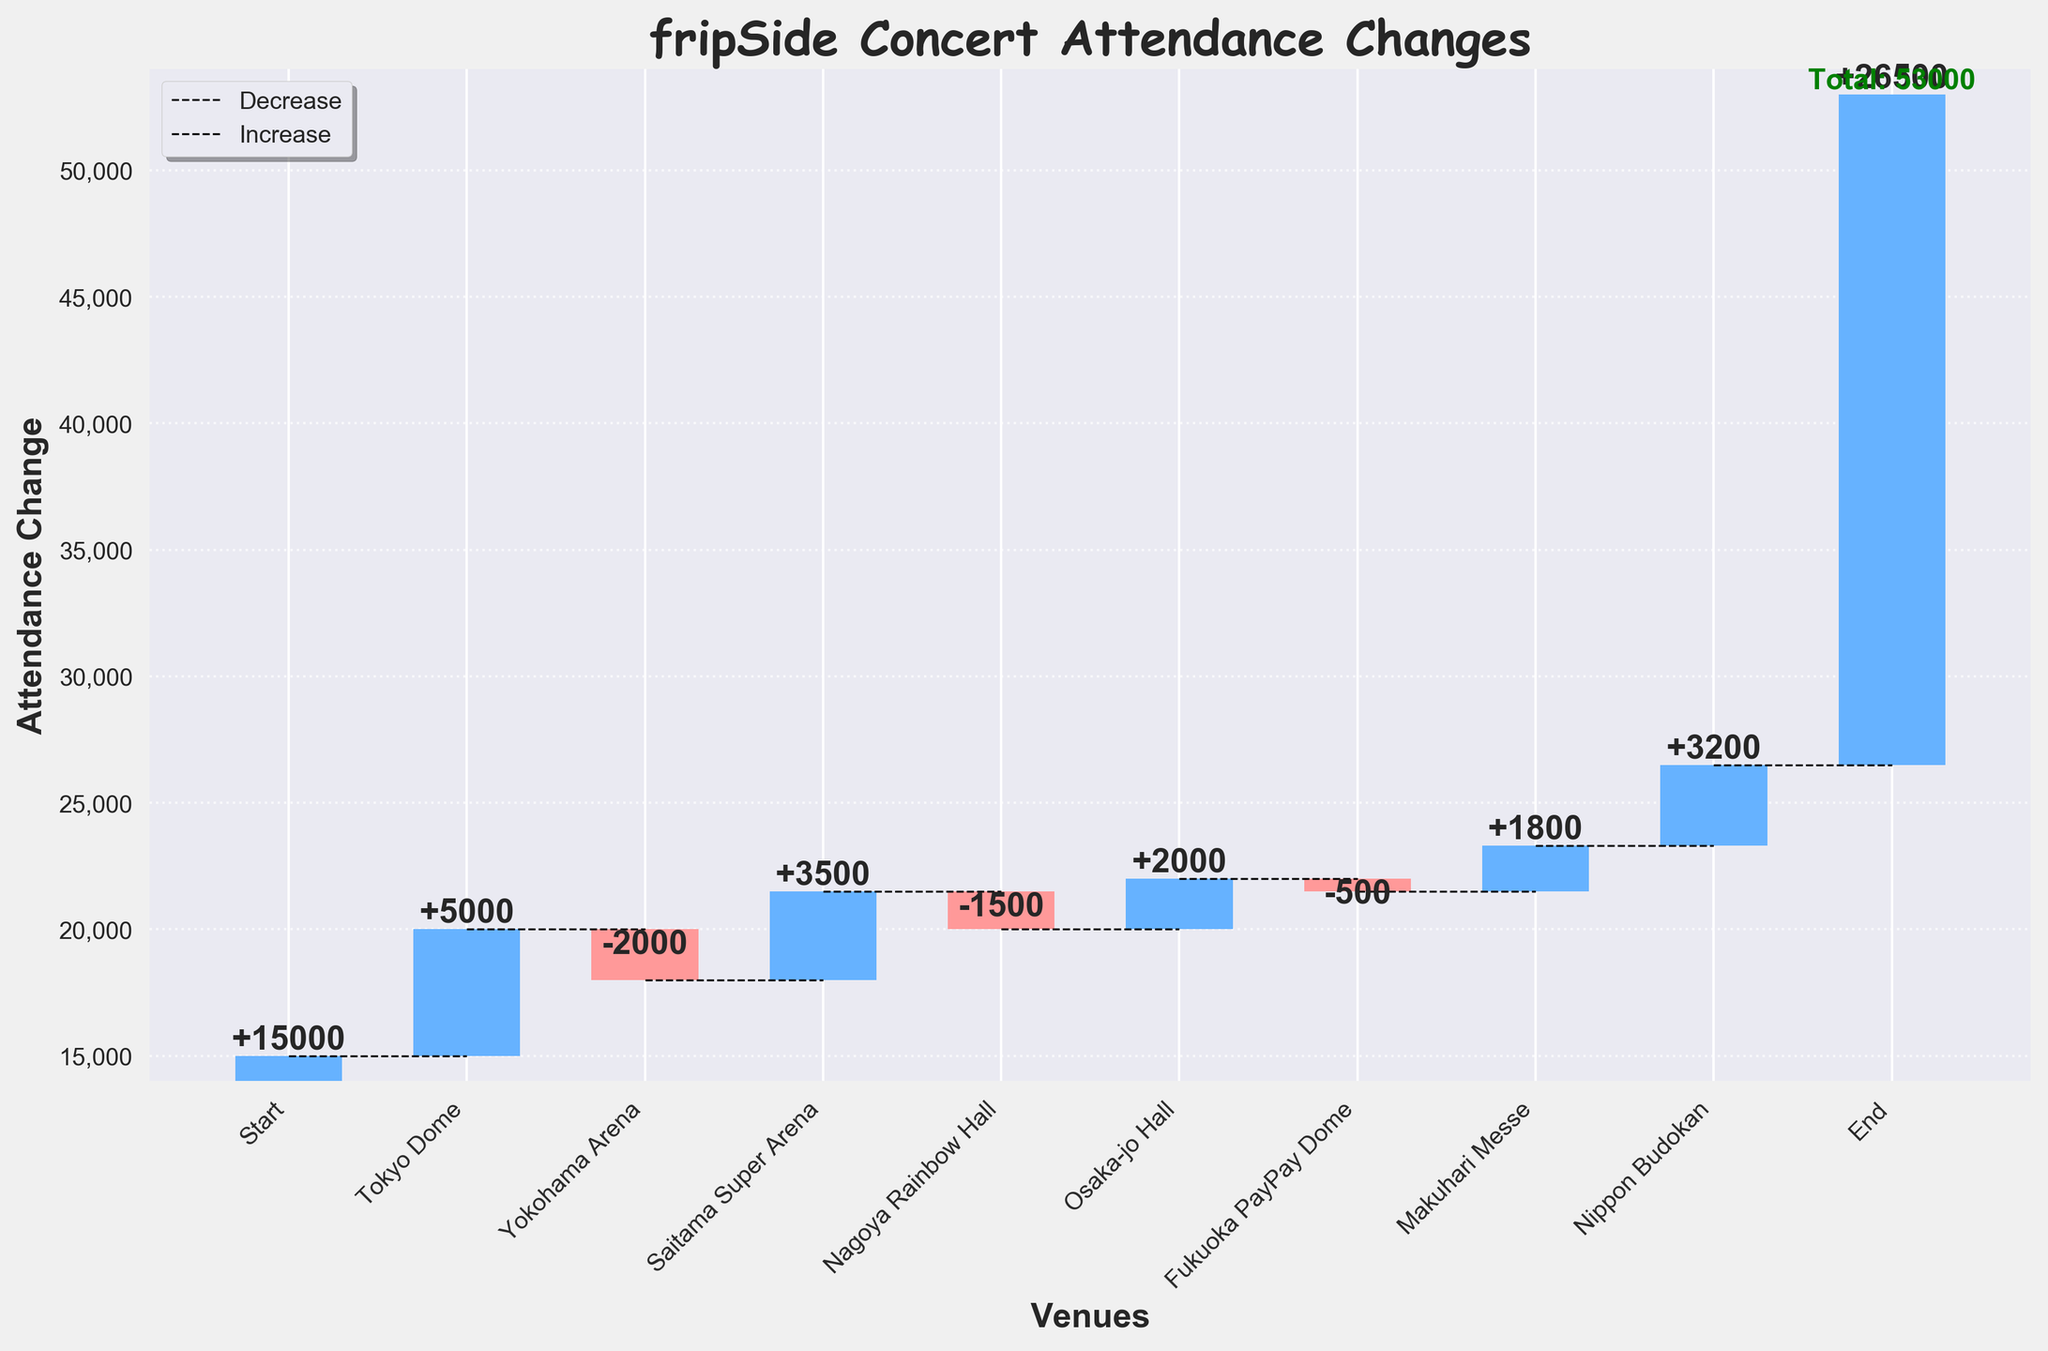What is the title of the Waterfall Chart? The title of the chart is prominently displayed at the top of the figure, making it easy to identify.
Answer: fripSide Concert Attendance Changes How many venues are represented in the Waterfall Chart? By counting the individual bars labeled with different venue names on the x-axis, excluding the Start and End points.
Answer: 8 What is the attendance change at the Tokyo Dome? Locate the bar labeled "Tokyo Dome" and read its height and color, indicating a positive change.
Answer: +5000 Which venue had the largest increase in concert attendance? Compare the heights of all positive bars to find the tallest one. Saitama Super Arena (+3500), Osaka-jo Hall (+2000), and Nippon Budokan (+3200) are positive, with Saitama Super Arena having the largest increase.
Answer: Saitama Super Arena What is the total attendance change from Start to End? Observe the first point labeled "Start" and the last point labeled "End" to note the cumulative change.
Answer: 26500 - 15000 = 11500 How did the attendance change at Yokohama Arena compare to Makuhari Messe? Compare the heights of the bars for Yokohama Arena and Makuhari Messe; Yokohama Arena decreased by 2000, while Makuhari Messe increased by 1800.
Answer: Yokohama Arena decreased by 2000, Makuhari Messe increased by 1800 What is the cumulative attendance change after the performance at Osaka-jo Hall? Sum the changes up to and including the Osaka-jo Hall: 15000 + 5000 - 2000 + 3500 - 1500 + 2000 = 22000
Answer: 22000 What is the difference in attendance change between Nagoya Rainbow Hall and Fukuoka PayPay Dome? Nagoya Rainbow Hall had a decline of 1500, while Fukuoka PayPay Dome had a decline of 500. The difference is 1500 - 500.
Answer: 1000 Which venue shows the smallest change in attendance? Identify the bar with the smallest height, either positive or negative; Fukuoka PayPay Dome shows the smallest change with -500.
Answer: Fukuoka PayPay Dome 